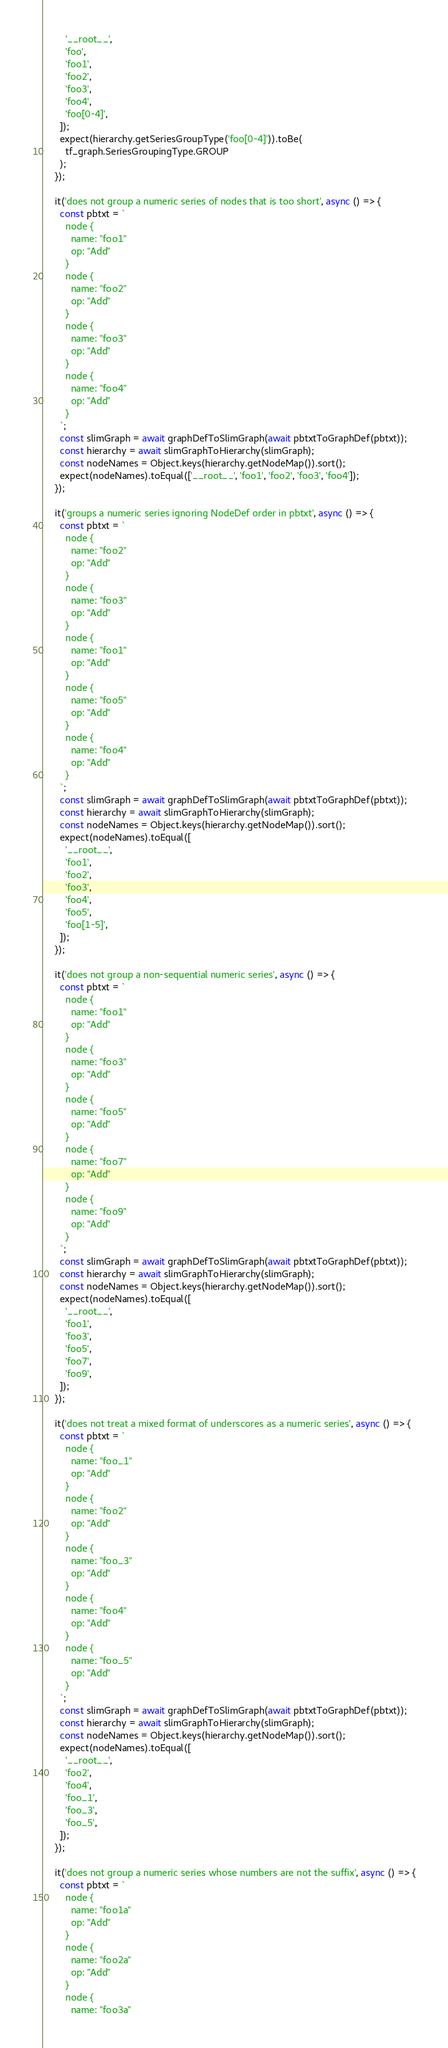<code> <loc_0><loc_0><loc_500><loc_500><_TypeScript_>        '__root__',
        'foo',
        'foo1',
        'foo2',
        'foo3',
        'foo4',
        'foo[0-4]',
      ]);
      expect(hierarchy.getSeriesGroupType('foo[0-4]')).toBe(
        tf_graph.SeriesGroupingType.GROUP
      );
    });

    it('does not group a numeric series of nodes that is too short', async () => {
      const pbtxt = `
        node {
          name: "foo1"
          op: "Add"
        }
        node {
          name: "foo2"
          op: "Add"
        }
        node {
          name: "foo3"
          op: "Add"
        }
        node {
          name: "foo4"
          op: "Add"
        }
      `;
      const slimGraph = await graphDefToSlimGraph(await pbtxtToGraphDef(pbtxt));
      const hierarchy = await slimGraphToHierarchy(slimGraph);
      const nodeNames = Object.keys(hierarchy.getNodeMap()).sort();
      expect(nodeNames).toEqual(['__root__', 'foo1', 'foo2', 'foo3', 'foo4']);
    });

    it('groups a numeric series ignoring NodeDef order in pbtxt', async () => {
      const pbtxt = `
        node {
          name: "foo2"
          op: "Add"
        }
        node {
          name: "foo3"
          op: "Add"
        }
        node {
          name: "foo1"
          op: "Add"
        }
        node {
          name: "foo5"
          op: "Add"
        }
        node {
          name: "foo4"
          op: "Add"
        }
      `;
      const slimGraph = await graphDefToSlimGraph(await pbtxtToGraphDef(pbtxt));
      const hierarchy = await slimGraphToHierarchy(slimGraph);
      const nodeNames = Object.keys(hierarchy.getNodeMap()).sort();
      expect(nodeNames).toEqual([
        '__root__',
        'foo1',
        'foo2',
        'foo3',
        'foo4',
        'foo5',
        'foo[1-5]',
      ]);
    });

    it('does not group a non-sequential numeric series', async () => {
      const pbtxt = `
        node {
          name: "foo1"
          op: "Add"
        }
        node {
          name: "foo3"
          op: "Add"
        }
        node {
          name: "foo5"
          op: "Add"
        }
        node {
          name: "foo7"
          op: "Add"
        }
        node {
          name: "foo9"
          op: "Add"
        }
      `;
      const slimGraph = await graphDefToSlimGraph(await pbtxtToGraphDef(pbtxt));
      const hierarchy = await slimGraphToHierarchy(slimGraph);
      const nodeNames = Object.keys(hierarchy.getNodeMap()).sort();
      expect(nodeNames).toEqual([
        '__root__',
        'foo1',
        'foo3',
        'foo5',
        'foo7',
        'foo9',
      ]);
    });

    it('does not treat a mixed format of underscores as a numeric series', async () => {
      const pbtxt = `
        node {
          name: "foo_1"
          op: "Add"
        }
        node {
          name: "foo2"
          op: "Add"
        }
        node {
          name: "foo_3"
          op: "Add"
        }
        node {
          name: "foo4"
          op: "Add"
        }
        node {
          name: "foo_5"
          op: "Add"
        }
      `;
      const slimGraph = await graphDefToSlimGraph(await pbtxtToGraphDef(pbtxt));
      const hierarchy = await slimGraphToHierarchy(slimGraph);
      const nodeNames = Object.keys(hierarchy.getNodeMap()).sort();
      expect(nodeNames).toEqual([
        '__root__',
        'foo2',
        'foo4',
        'foo_1',
        'foo_3',
        'foo_5',
      ]);
    });

    it('does not group a numeric series whose numbers are not the suffix', async () => {
      const pbtxt = `
        node {
          name: "foo1a"
          op: "Add"
        }
        node {
          name: "foo2a"
          op: "Add"
        }
        node {
          name: "foo3a"</code> 